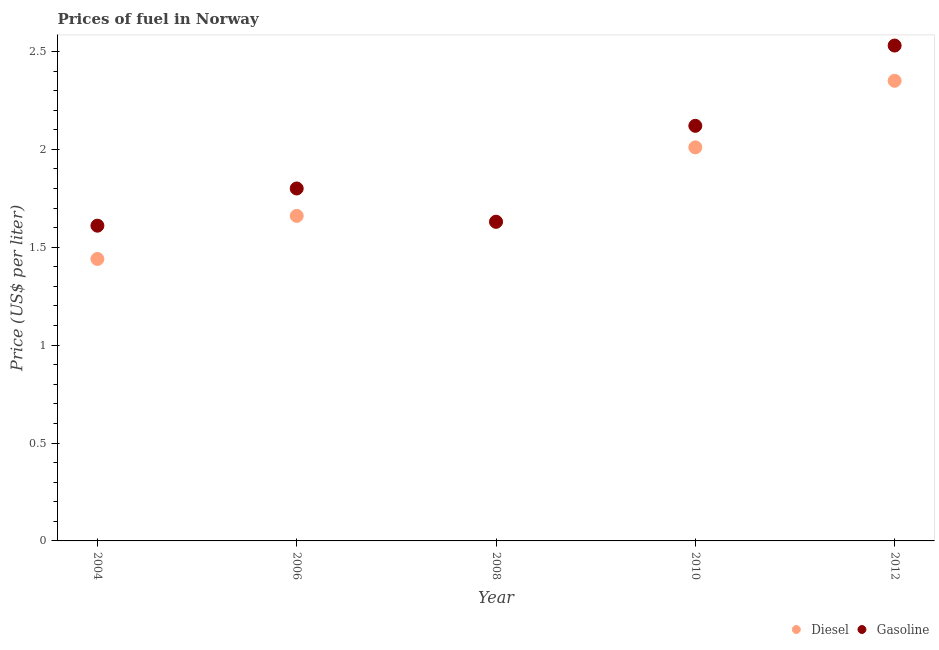How many different coloured dotlines are there?
Provide a succinct answer. 2. What is the diesel price in 2006?
Offer a terse response. 1.66. Across all years, what is the maximum diesel price?
Provide a short and direct response. 2.35. Across all years, what is the minimum diesel price?
Keep it short and to the point. 1.44. In which year was the gasoline price minimum?
Give a very brief answer. 2004. What is the total gasoline price in the graph?
Your answer should be compact. 9.69. What is the difference between the diesel price in 2004 and that in 2006?
Provide a succinct answer. -0.22. What is the difference between the gasoline price in 2008 and the diesel price in 2004?
Provide a short and direct response. 0.19. What is the average diesel price per year?
Your answer should be very brief. 1.82. In the year 2012, what is the difference between the diesel price and gasoline price?
Ensure brevity in your answer.  -0.18. In how many years, is the diesel price greater than 1.8 US$ per litre?
Make the answer very short. 2. What is the ratio of the diesel price in 2008 to that in 2012?
Provide a succinct answer. 0.69. Is the gasoline price in 2004 less than that in 2012?
Offer a terse response. Yes. What is the difference between the highest and the second highest diesel price?
Offer a terse response. 0.34. What is the difference between the highest and the lowest diesel price?
Keep it short and to the point. 0.91. In how many years, is the gasoline price greater than the average gasoline price taken over all years?
Give a very brief answer. 2. Is the sum of the gasoline price in 2006 and 2008 greater than the maximum diesel price across all years?
Ensure brevity in your answer.  Yes. Is the gasoline price strictly greater than the diesel price over the years?
Your answer should be compact. No. How many dotlines are there?
Your answer should be very brief. 2. How many years are there in the graph?
Provide a succinct answer. 5. What is the difference between two consecutive major ticks on the Y-axis?
Ensure brevity in your answer.  0.5. Are the values on the major ticks of Y-axis written in scientific E-notation?
Your response must be concise. No. Does the graph contain grids?
Your response must be concise. No. How many legend labels are there?
Your response must be concise. 2. How are the legend labels stacked?
Offer a very short reply. Horizontal. What is the title of the graph?
Your answer should be compact. Prices of fuel in Norway. What is the label or title of the Y-axis?
Give a very brief answer. Price (US$ per liter). What is the Price (US$ per liter) of Diesel in 2004?
Keep it short and to the point. 1.44. What is the Price (US$ per liter) of Gasoline in 2004?
Give a very brief answer. 1.61. What is the Price (US$ per liter) of Diesel in 2006?
Make the answer very short. 1.66. What is the Price (US$ per liter) of Gasoline in 2006?
Your answer should be compact. 1.8. What is the Price (US$ per liter) of Diesel in 2008?
Your answer should be very brief. 1.63. What is the Price (US$ per liter) of Gasoline in 2008?
Ensure brevity in your answer.  1.63. What is the Price (US$ per liter) in Diesel in 2010?
Provide a short and direct response. 2.01. What is the Price (US$ per liter) of Gasoline in 2010?
Provide a succinct answer. 2.12. What is the Price (US$ per liter) of Diesel in 2012?
Make the answer very short. 2.35. What is the Price (US$ per liter) of Gasoline in 2012?
Provide a short and direct response. 2.53. Across all years, what is the maximum Price (US$ per liter) in Diesel?
Your answer should be very brief. 2.35. Across all years, what is the maximum Price (US$ per liter) in Gasoline?
Provide a succinct answer. 2.53. Across all years, what is the minimum Price (US$ per liter) in Diesel?
Offer a terse response. 1.44. Across all years, what is the minimum Price (US$ per liter) of Gasoline?
Make the answer very short. 1.61. What is the total Price (US$ per liter) of Diesel in the graph?
Your answer should be very brief. 9.09. What is the total Price (US$ per liter) of Gasoline in the graph?
Provide a succinct answer. 9.69. What is the difference between the Price (US$ per liter) in Diesel in 2004 and that in 2006?
Ensure brevity in your answer.  -0.22. What is the difference between the Price (US$ per liter) of Gasoline in 2004 and that in 2006?
Your answer should be very brief. -0.19. What is the difference between the Price (US$ per liter) in Diesel in 2004 and that in 2008?
Offer a terse response. -0.19. What is the difference between the Price (US$ per liter) of Gasoline in 2004 and that in 2008?
Your response must be concise. -0.02. What is the difference between the Price (US$ per liter) in Diesel in 2004 and that in 2010?
Provide a succinct answer. -0.57. What is the difference between the Price (US$ per liter) in Gasoline in 2004 and that in 2010?
Offer a terse response. -0.51. What is the difference between the Price (US$ per liter) of Diesel in 2004 and that in 2012?
Offer a very short reply. -0.91. What is the difference between the Price (US$ per liter) of Gasoline in 2004 and that in 2012?
Your answer should be compact. -0.92. What is the difference between the Price (US$ per liter) of Diesel in 2006 and that in 2008?
Provide a succinct answer. 0.03. What is the difference between the Price (US$ per liter) of Gasoline in 2006 and that in 2008?
Your answer should be compact. 0.17. What is the difference between the Price (US$ per liter) in Diesel in 2006 and that in 2010?
Your response must be concise. -0.35. What is the difference between the Price (US$ per liter) of Gasoline in 2006 and that in 2010?
Give a very brief answer. -0.32. What is the difference between the Price (US$ per liter) of Diesel in 2006 and that in 2012?
Offer a terse response. -0.69. What is the difference between the Price (US$ per liter) in Gasoline in 2006 and that in 2012?
Provide a succinct answer. -0.73. What is the difference between the Price (US$ per liter) in Diesel in 2008 and that in 2010?
Make the answer very short. -0.38. What is the difference between the Price (US$ per liter) of Gasoline in 2008 and that in 2010?
Keep it short and to the point. -0.49. What is the difference between the Price (US$ per liter) in Diesel in 2008 and that in 2012?
Provide a short and direct response. -0.72. What is the difference between the Price (US$ per liter) of Gasoline in 2008 and that in 2012?
Give a very brief answer. -0.9. What is the difference between the Price (US$ per liter) in Diesel in 2010 and that in 2012?
Provide a succinct answer. -0.34. What is the difference between the Price (US$ per liter) in Gasoline in 2010 and that in 2012?
Keep it short and to the point. -0.41. What is the difference between the Price (US$ per liter) of Diesel in 2004 and the Price (US$ per liter) of Gasoline in 2006?
Provide a succinct answer. -0.36. What is the difference between the Price (US$ per liter) of Diesel in 2004 and the Price (US$ per liter) of Gasoline in 2008?
Offer a very short reply. -0.19. What is the difference between the Price (US$ per liter) of Diesel in 2004 and the Price (US$ per liter) of Gasoline in 2010?
Give a very brief answer. -0.68. What is the difference between the Price (US$ per liter) of Diesel in 2004 and the Price (US$ per liter) of Gasoline in 2012?
Ensure brevity in your answer.  -1.09. What is the difference between the Price (US$ per liter) in Diesel in 2006 and the Price (US$ per liter) in Gasoline in 2010?
Offer a very short reply. -0.46. What is the difference between the Price (US$ per liter) in Diesel in 2006 and the Price (US$ per liter) in Gasoline in 2012?
Offer a terse response. -0.87. What is the difference between the Price (US$ per liter) in Diesel in 2008 and the Price (US$ per liter) in Gasoline in 2010?
Ensure brevity in your answer.  -0.49. What is the difference between the Price (US$ per liter) in Diesel in 2008 and the Price (US$ per liter) in Gasoline in 2012?
Your response must be concise. -0.9. What is the difference between the Price (US$ per liter) in Diesel in 2010 and the Price (US$ per liter) in Gasoline in 2012?
Make the answer very short. -0.52. What is the average Price (US$ per liter) of Diesel per year?
Provide a succinct answer. 1.82. What is the average Price (US$ per liter) of Gasoline per year?
Offer a terse response. 1.94. In the year 2004, what is the difference between the Price (US$ per liter) in Diesel and Price (US$ per liter) in Gasoline?
Keep it short and to the point. -0.17. In the year 2006, what is the difference between the Price (US$ per liter) in Diesel and Price (US$ per liter) in Gasoline?
Provide a short and direct response. -0.14. In the year 2010, what is the difference between the Price (US$ per liter) of Diesel and Price (US$ per liter) of Gasoline?
Keep it short and to the point. -0.11. In the year 2012, what is the difference between the Price (US$ per liter) of Diesel and Price (US$ per liter) of Gasoline?
Offer a terse response. -0.18. What is the ratio of the Price (US$ per liter) in Diesel in 2004 to that in 2006?
Provide a succinct answer. 0.87. What is the ratio of the Price (US$ per liter) in Gasoline in 2004 to that in 2006?
Offer a very short reply. 0.89. What is the ratio of the Price (US$ per liter) of Diesel in 2004 to that in 2008?
Your answer should be very brief. 0.88. What is the ratio of the Price (US$ per liter) of Diesel in 2004 to that in 2010?
Keep it short and to the point. 0.72. What is the ratio of the Price (US$ per liter) in Gasoline in 2004 to that in 2010?
Give a very brief answer. 0.76. What is the ratio of the Price (US$ per liter) in Diesel in 2004 to that in 2012?
Offer a very short reply. 0.61. What is the ratio of the Price (US$ per liter) in Gasoline in 2004 to that in 2012?
Your answer should be very brief. 0.64. What is the ratio of the Price (US$ per liter) of Diesel in 2006 to that in 2008?
Keep it short and to the point. 1.02. What is the ratio of the Price (US$ per liter) of Gasoline in 2006 to that in 2008?
Keep it short and to the point. 1.1. What is the ratio of the Price (US$ per liter) of Diesel in 2006 to that in 2010?
Provide a short and direct response. 0.83. What is the ratio of the Price (US$ per liter) in Gasoline in 2006 to that in 2010?
Provide a succinct answer. 0.85. What is the ratio of the Price (US$ per liter) in Diesel in 2006 to that in 2012?
Ensure brevity in your answer.  0.71. What is the ratio of the Price (US$ per liter) of Gasoline in 2006 to that in 2012?
Your answer should be compact. 0.71. What is the ratio of the Price (US$ per liter) in Diesel in 2008 to that in 2010?
Make the answer very short. 0.81. What is the ratio of the Price (US$ per liter) in Gasoline in 2008 to that in 2010?
Ensure brevity in your answer.  0.77. What is the ratio of the Price (US$ per liter) in Diesel in 2008 to that in 2012?
Your response must be concise. 0.69. What is the ratio of the Price (US$ per liter) in Gasoline in 2008 to that in 2012?
Ensure brevity in your answer.  0.64. What is the ratio of the Price (US$ per liter) of Diesel in 2010 to that in 2012?
Your answer should be very brief. 0.86. What is the ratio of the Price (US$ per liter) of Gasoline in 2010 to that in 2012?
Your answer should be compact. 0.84. What is the difference between the highest and the second highest Price (US$ per liter) in Diesel?
Your answer should be compact. 0.34. What is the difference between the highest and the second highest Price (US$ per liter) in Gasoline?
Offer a very short reply. 0.41. What is the difference between the highest and the lowest Price (US$ per liter) in Diesel?
Your response must be concise. 0.91. 